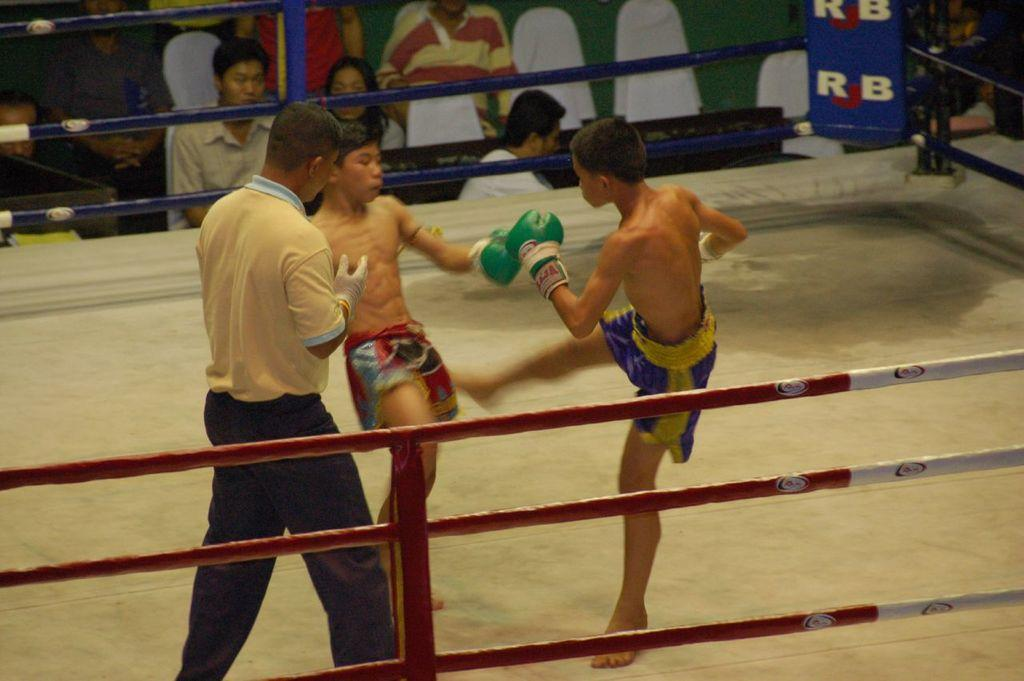Provide a one-sentence caption for the provided image. Two young kickboxers compete in a ring with RJB signs on it. 